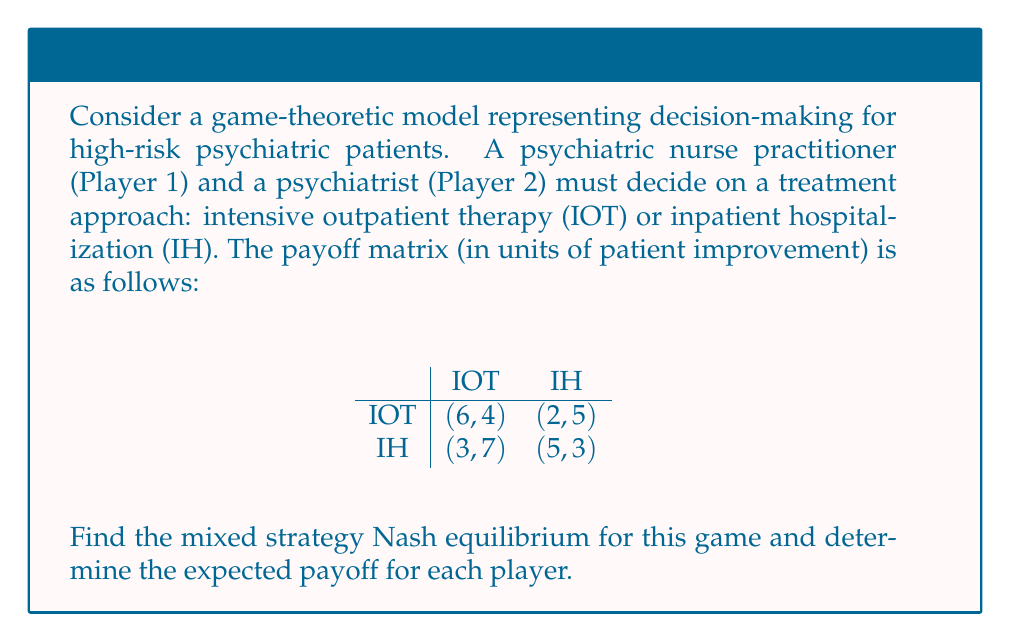Teach me how to tackle this problem. To find the mixed strategy Nash equilibrium, we need to make each player indifferent between their strategies:

1. Let $p$ be the probability that Player 1 chooses IOT, and $1-p$ the probability of choosing IH.
2. Let $q$ be the probability that Player 2 chooses IOT, and $1-q$ the probability of choosing IH.

For Player 2 to be indifferent:

$$ 4p + 7(1-p) = 5p + 3(1-p) $$
$$ 4p + 7 - 7p = 5p + 3 - 3p $$
$$ 7 - 3p = 3 + 2p $$
$$ 4 = 5p $$
$$ p = \frac{4}{5} = 0.8 $$

For Player 1 to be indifferent:

$$ 6q + 2(1-q) = 3q + 5(1-q) $$
$$ 6q + 2 - 2q = 3q + 5 - 5q $$
$$ 4q + 2 = -2q + 5 $$
$$ 6q = 3 $$
$$ q = \frac{1}{2} = 0.5 $$

The mixed strategy Nash equilibrium is $(p, q) = (0.8, 0.5)$.

To calculate the expected payoff for each player:

Player 1's expected payoff:
$$ E_1 = 0.8(0.5(6) + 0.5(2)) + 0.2(0.5(3) + 0.5(5)) = 4 $$

Player 2's expected payoff:
$$ E_2 = 0.5(0.8(4) + 0.2(7)) + 0.5(0.8(5) + 0.2(3)) = 4.5 $$
Answer: The mixed strategy Nash equilibrium is $(p, q) = (0.8, 0.5)$, where Player 1 (psychiatric nurse practitioner) chooses IOT with probability 0.8 and IH with probability 0.2, and Player 2 (psychiatrist) chooses IOT with probability 0.5 and IH with probability 0.5. The expected payoff for Player 1 is 4 units, and for Player 2 is 4.5 units. 